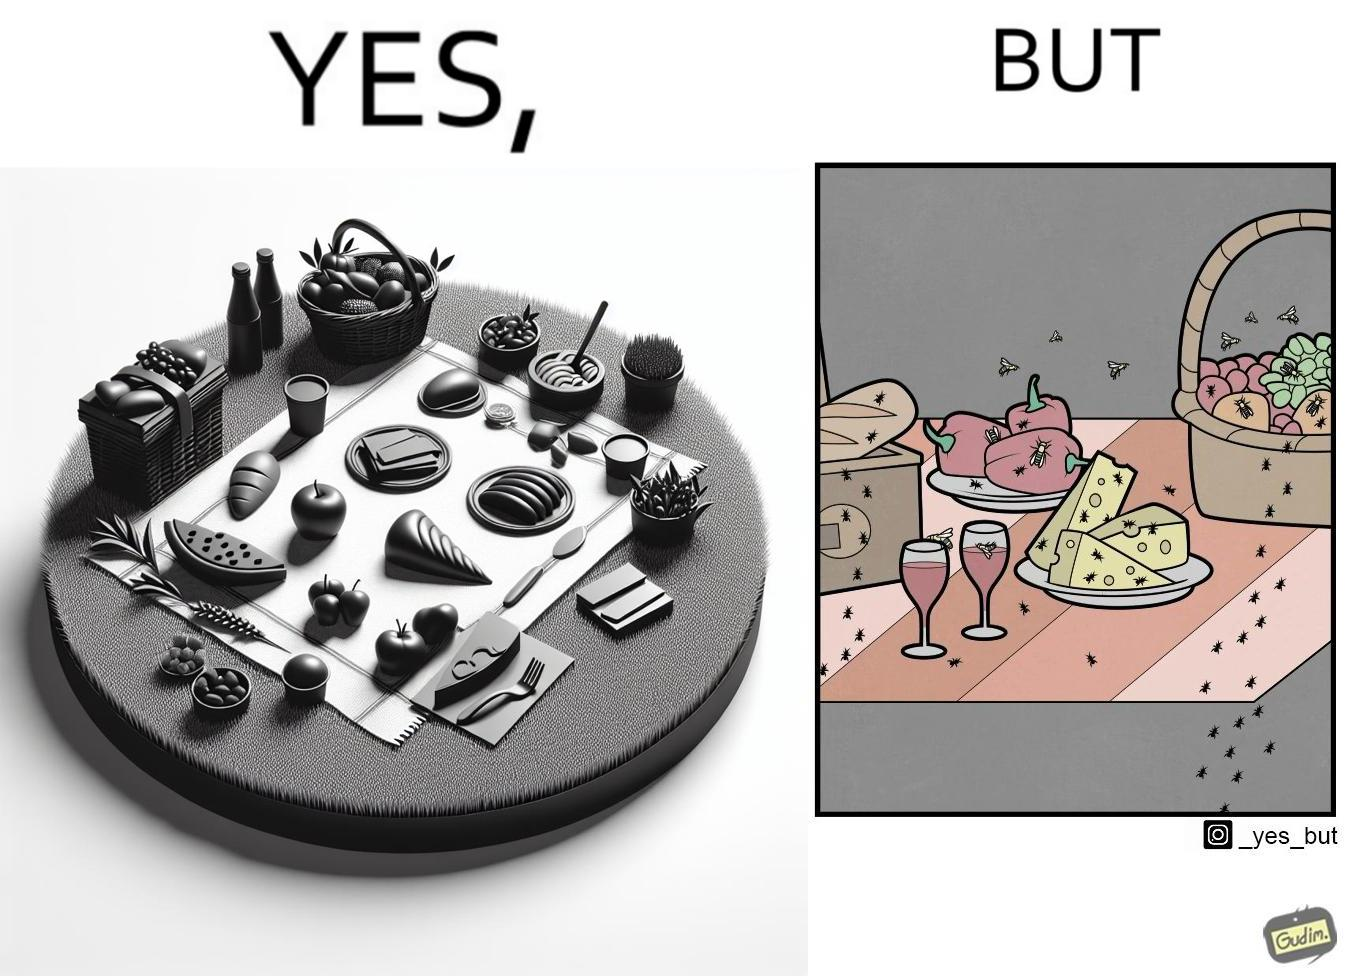What makes this image funny or satirical? The Picture shows that although we enjoy food in garden but there are some consequences of eating food in garden. Many bugs and bees are attracted towards our food and make our food sometimes non-eatable. 